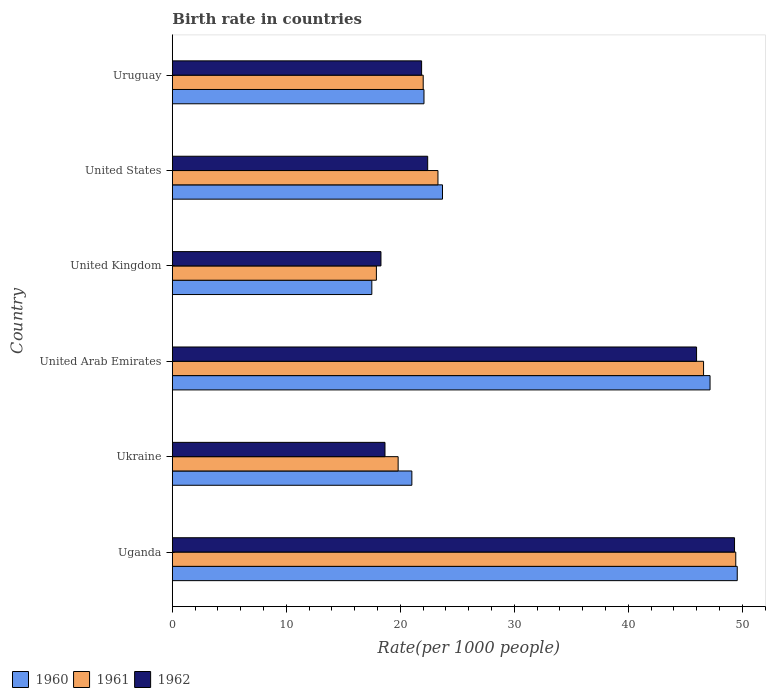What is the label of the 4th group of bars from the top?
Keep it short and to the point. United Arab Emirates. What is the birth rate in 1961 in Uruguay?
Offer a terse response. 22.01. Across all countries, what is the maximum birth rate in 1962?
Your answer should be compact. 49.32. In which country was the birth rate in 1960 maximum?
Give a very brief answer. Uganda. In which country was the birth rate in 1961 minimum?
Offer a very short reply. United Kingdom. What is the total birth rate in 1961 in the graph?
Your response must be concise. 179.04. What is the difference between the birth rate in 1961 in United Kingdom and that in Uruguay?
Make the answer very short. -4.11. What is the difference between the birth rate in 1961 in Uganda and the birth rate in 1962 in Ukraine?
Keep it short and to the point. 30.77. What is the average birth rate in 1962 per country?
Provide a short and direct response. 29.42. What is the difference between the birth rate in 1962 and birth rate in 1960 in United States?
Provide a short and direct response. -1.3. In how many countries, is the birth rate in 1960 greater than 40 ?
Provide a short and direct response. 2. What is the ratio of the birth rate in 1960 in Ukraine to that in United Arab Emirates?
Your response must be concise. 0.45. Is the birth rate in 1960 in Uganda less than that in United States?
Provide a succinct answer. No. What is the difference between the highest and the second highest birth rate in 1960?
Give a very brief answer. 2.39. What is the difference between the highest and the lowest birth rate in 1962?
Keep it short and to the point. 31.02. Is the sum of the birth rate in 1960 in Uganda and United Kingdom greater than the maximum birth rate in 1962 across all countries?
Ensure brevity in your answer.  Yes. What does the 1st bar from the top in United Arab Emirates represents?
Make the answer very short. 1962. Are all the bars in the graph horizontal?
Your answer should be compact. Yes. What is the difference between two consecutive major ticks on the X-axis?
Keep it short and to the point. 10. Does the graph contain any zero values?
Provide a succinct answer. No. Where does the legend appear in the graph?
Offer a very short reply. Bottom left. How are the legend labels stacked?
Provide a short and direct response. Horizontal. What is the title of the graph?
Offer a terse response. Birth rate in countries. What is the label or title of the X-axis?
Ensure brevity in your answer.  Rate(per 1000 people). What is the label or title of the Y-axis?
Make the answer very short. Country. What is the Rate(per 1000 people) in 1960 in Uganda?
Give a very brief answer. 49.56. What is the Rate(per 1000 people) of 1961 in Uganda?
Make the answer very short. 49.43. What is the Rate(per 1000 people) of 1962 in Uganda?
Give a very brief answer. 49.32. What is the Rate(per 1000 people) in 1960 in Ukraine?
Provide a succinct answer. 21.01. What is the Rate(per 1000 people) in 1961 in Ukraine?
Your answer should be compact. 19.81. What is the Rate(per 1000 people) of 1962 in Ukraine?
Give a very brief answer. 18.65. What is the Rate(per 1000 people) of 1960 in United Arab Emirates?
Your answer should be compact. 47.17. What is the Rate(per 1000 people) of 1961 in United Arab Emirates?
Offer a very short reply. 46.6. What is the Rate(per 1000 people) in 1962 in United Arab Emirates?
Keep it short and to the point. 45.99. What is the Rate(per 1000 people) of 1960 in United Kingdom?
Give a very brief answer. 17.5. What is the Rate(per 1000 people) of 1960 in United States?
Ensure brevity in your answer.  23.7. What is the Rate(per 1000 people) in 1961 in United States?
Provide a short and direct response. 23.3. What is the Rate(per 1000 people) of 1962 in United States?
Offer a terse response. 22.4. What is the Rate(per 1000 people) of 1960 in Uruguay?
Your answer should be very brief. 22.07. What is the Rate(per 1000 people) of 1961 in Uruguay?
Give a very brief answer. 22.01. What is the Rate(per 1000 people) in 1962 in Uruguay?
Provide a short and direct response. 21.87. Across all countries, what is the maximum Rate(per 1000 people) of 1960?
Your response must be concise. 49.56. Across all countries, what is the maximum Rate(per 1000 people) in 1961?
Your answer should be very brief. 49.43. Across all countries, what is the maximum Rate(per 1000 people) in 1962?
Provide a short and direct response. 49.32. Across all countries, what is the minimum Rate(per 1000 people) of 1960?
Your answer should be compact. 17.5. Across all countries, what is the minimum Rate(per 1000 people) in 1961?
Your answer should be very brief. 17.9. Across all countries, what is the minimum Rate(per 1000 people) in 1962?
Make the answer very short. 18.3. What is the total Rate(per 1000 people) of 1960 in the graph?
Offer a terse response. 181.01. What is the total Rate(per 1000 people) in 1961 in the graph?
Ensure brevity in your answer.  179.04. What is the total Rate(per 1000 people) in 1962 in the graph?
Your answer should be compact. 176.53. What is the difference between the Rate(per 1000 people) of 1960 in Uganda and that in Ukraine?
Give a very brief answer. 28.55. What is the difference between the Rate(per 1000 people) of 1961 in Uganda and that in Ukraine?
Ensure brevity in your answer.  29.62. What is the difference between the Rate(per 1000 people) of 1962 in Uganda and that in Ukraine?
Offer a terse response. 30.66. What is the difference between the Rate(per 1000 people) of 1960 in Uganda and that in United Arab Emirates?
Your answer should be very brief. 2.39. What is the difference between the Rate(per 1000 people) in 1961 in Uganda and that in United Arab Emirates?
Offer a very short reply. 2.83. What is the difference between the Rate(per 1000 people) in 1962 in Uganda and that in United Arab Emirates?
Keep it short and to the point. 3.33. What is the difference between the Rate(per 1000 people) in 1960 in Uganda and that in United Kingdom?
Your answer should be very brief. 32.06. What is the difference between the Rate(per 1000 people) in 1961 in Uganda and that in United Kingdom?
Provide a short and direct response. 31.53. What is the difference between the Rate(per 1000 people) of 1962 in Uganda and that in United Kingdom?
Your answer should be compact. 31.02. What is the difference between the Rate(per 1000 people) in 1960 in Uganda and that in United States?
Provide a short and direct response. 25.86. What is the difference between the Rate(per 1000 people) of 1961 in Uganda and that in United States?
Offer a terse response. 26.13. What is the difference between the Rate(per 1000 people) in 1962 in Uganda and that in United States?
Offer a terse response. 26.92. What is the difference between the Rate(per 1000 people) in 1960 in Uganda and that in Uruguay?
Provide a succinct answer. 27.48. What is the difference between the Rate(per 1000 people) in 1961 in Uganda and that in Uruguay?
Your answer should be compact. 27.42. What is the difference between the Rate(per 1000 people) in 1962 in Uganda and that in Uruguay?
Make the answer very short. 27.45. What is the difference between the Rate(per 1000 people) of 1960 in Ukraine and that in United Arab Emirates?
Offer a very short reply. -26.16. What is the difference between the Rate(per 1000 people) of 1961 in Ukraine and that in United Arab Emirates?
Give a very brief answer. -26.79. What is the difference between the Rate(per 1000 people) of 1962 in Ukraine and that in United Arab Emirates?
Offer a terse response. -27.33. What is the difference between the Rate(per 1000 people) of 1960 in Ukraine and that in United Kingdom?
Give a very brief answer. 3.51. What is the difference between the Rate(per 1000 people) in 1961 in Ukraine and that in United Kingdom?
Give a very brief answer. 1.91. What is the difference between the Rate(per 1000 people) in 1962 in Ukraine and that in United Kingdom?
Ensure brevity in your answer.  0.35. What is the difference between the Rate(per 1000 people) of 1960 in Ukraine and that in United States?
Ensure brevity in your answer.  -2.69. What is the difference between the Rate(per 1000 people) of 1961 in Ukraine and that in United States?
Ensure brevity in your answer.  -3.49. What is the difference between the Rate(per 1000 people) of 1962 in Ukraine and that in United States?
Make the answer very short. -3.75. What is the difference between the Rate(per 1000 people) of 1960 in Ukraine and that in Uruguay?
Provide a succinct answer. -1.06. What is the difference between the Rate(per 1000 people) in 1961 in Ukraine and that in Uruguay?
Keep it short and to the point. -2.2. What is the difference between the Rate(per 1000 people) of 1962 in Ukraine and that in Uruguay?
Offer a very short reply. -3.21. What is the difference between the Rate(per 1000 people) in 1960 in United Arab Emirates and that in United Kingdom?
Offer a terse response. 29.67. What is the difference between the Rate(per 1000 people) of 1961 in United Arab Emirates and that in United Kingdom?
Your answer should be very brief. 28.7. What is the difference between the Rate(per 1000 people) in 1962 in United Arab Emirates and that in United Kingdom?
Provide a short and direct response. 27.69. What is the difference between the Rate(per 1000 people) in 1960 in United Arab Emirates and that in United States?
Provide a short and direct response. 23.47. What is the difference between the Rate(per 1000 people) of 1961 in United Arab Emirates and that in United States?
Offer a terse response. 23.3. What is the difference between the Rate(per 1000 people) of 1962 in United Arab Emirates and that in United States?
Your answer should be compact. 23.59. What is the difference between the Rate(per 1000 people) in 1960 in United Arab Emirates and that in Uruguay?
Provide a short and direct response. 25.1. What is the difference between the Rate(per 1000 people) in 1961 in United Arab Emirates and that in Uruguay?
Keep it short and to the point. 24.59. What is the difference between the Rate(per 1000 people) of 1962 in United Arab Emirates and that in Uruguay?
Give a very brief answer. 24.12. What is the difference between the Rate(per 1000 people) in 1960 in United Kingdom and that in United States?
Your answer should be very brief. -6.2. What is the difference between the Rate(per 1000 people) in 1961 in United Kingdom and that in United States?
Provide a succinct answer. -5.4. What is the difference between the Rate(per 1000 people) of 1960 in United Kingdom and that in Uruguay?
Give a very brief answer. -4.58. What is the difference between the Rate(per 1000 people) of 1961 in United Kingdom and that in Uruguay?
Ensure brevity in your answer.  -4.11. What is the difference between the Rate(per 1000 people) of 1962 in United Kingdom and that in Uruguay?
Ensure brevity in your answer.  -3.57. What is the difference between the Rate(per 1000 people) in 1960 in United States and that in Uruguay?
Offer a very short reply. 1.62. What is the difference between the Rate(per 1000 people) of 1961 in United States and that in Uruguay?
Keep it short and to the point. 1.29. What is the difference between the Rate(per 1000 people) in 1962 in United States and that in Uruguay?
Provide a short and direct response. 0.53. What is the difference between the Rate(per 1000 people) in 1960 in Uganda and the Rate(per 1000 people) in 1961 in Ukraine?
Your answer should be very brief. 29.75. What is the difference between the Rate(per 1000 people) in 1960 in Uganda and the Rate(per 1000 people) in 1962 in Ukraine?
Your answer should be compact. 30.9. What is the difference between the Rate(per 1000 people) in 1961 in Uganda and the Rate(per 1000 people) in 1962 in Ukraine?
Your answer should be compact. 30.77. What is the difference between the Rate(per 1000 people) in 1960 in Uganda and the Rate(per 1000 people) in 1961 in United Arab Emirates?
Provide a succinct answer. 2.96. What is the difference between the Rate(per 1000 people) of 1960 in Uganda and the Rate(per 1000 people) of 1962 in United Arab Emirates?
Give a very brief answer. 3.57. What is the difference between the Rate(per 1000 people) in 1961 in Uganda and the Rate(per 1000 people) in 1962 in United Arab Emirates?
Provide a short and direct response. 3.44. What is the difference between the Rate(per 1000 people) in 1960 in Uganda and the Rate(per 1000 people) in 1961 in United Kingdom?
Your answer should be very brief. 31.66. What is the difference between the Rate(per 1000 people) of 1960 in Uganda and the Rate(per 1000 people) of 1962 in United Kingdom?
Ensure brevity in your answer.  31.26. What is the difference between the Rate(per 1000 people) in 1961 in Uganda and the Rate(per 1000 people) in 1962 in United Kingdom?
Offer a terse response. 31.13. What is the difference between the Rate(per 1000 people) in 1960 in Uganda and the Rate(per 1000 people) in 1961 in United States?
Offer a terse response. 26.26. What is the difference between the Rate(per 1000 people) in 1960 in Uganda and the Rate(per 1000 people) in 1962 in United States?
Your response must be concise. 27.16. What is the difference between the Rate(per 1000 people) in 1961 in Uganda and the Rate(per 1000 people) in 1962 in United States?
Provide a succinct answer. 27.03. What is the difference between the Rate(per 1000 people) in 1960 in Uganda and the Rate(per 1000 people) in 1961 in Uruguay?
Your answer should be compact. 27.55. What is the difference between the Rate(per 1000 people) in 1960 in Uganda and the Rate(per 1000 people) in 1962 in Uruguay?
Provide a short and direct response. 27.69. What is the difference between the Rate(per 1000 people) in 1961 in Uganda and the Rate(per 1000 people) in 1962 in Uruguay?
Your response must be concise. 27.56. What is the difference between the Rate(per 1000 people) in 1960 in Ukraine and the Rate(per 1000 people) in 1961 in United Arab Emirates?
Offer a very short reply. -25.59. What is the difference between the Rate(per 1000 people) of 1960 in Ukraine and the Rate(per 1000 people) of 1962 in United Arab Emirates?
Offer a very short reply. -24.98. What is the difference between the Rate(per 1000 people) of 1961 in Ukraine and the Rate(per 1000 people) of 1962 in United Arab Emirates?
Your answer should be very brief. -26.18. What is the difference between the Rate(per 1000 people) in 1960 in Ukraine and the Rate(per 1000 people) in 1961 in United Kingdom?
Your answer should be compact. 3.11. What is the difference between the Rate(per 1000 people) of 1960 in Ukraine and the Rate(per 1000 people) of 1962 in United Kingdom?
Provide a short and direct response. 2.71. What is the difference between the Rate(per 1000 people) in 1961 in Ukraine and the Rate(per 1000 people) in 1962 in United Kingdom?
Your answer should be very brief. 1.51. What is the difference between the Rate(per 1000 people) in 1960 in Ukraine and the Rate(per 1000 people) in 1961 in United States?
Provide a succinct answer. -2.29. What is the difference between the Rate(per 1000 people) of 1960 in Ukraine and the Rate(per 1000 people) of 1962 in United States?
Keep it short and to the point. -1.39. What is the difference between the Rate(per 1000 people) of 1961 in Ukraine and the Rate(per 1000 people) of 1962 in United States?
Ensure brevity in your answer.  -2.59. What is the difference between the Rate(per 1000 people) in 1960 in Ukraine and the Rate(per 1000 people) in 1961 in Uruguay?
Provide a short and direct response. -1. What is the difference between the Rate(per 1000 people) of 1960 in Ukraine and the Rate(per 1000 people) of 1962 in Uruguay?
Offer a terse response. -0.86. What is the difference between the Rate(per 1000 people) in 1961 in Ukraine and the Rate(per 1000 people) in 1962 in Uruguay?
Provide a succinct answer. -2.06. What is the difference between the Rate(per 1000 people) in 1960 in United Arab Emirates and the Rate(per 1000 people) in 1961 in United Kingdom?
Provide a succinct answer. 29.27. What is the difference between the Rate(per 1000 people) in 1960 in United Arab Emirates and the Rate(per 1000 people) in 1962 in United Kingdom?
Make the answer very short. 28.87. What is the difference between the Rate(per 1000 people) in 1961 in United Arab Emirates and the Rate(per 1000 people) in 1962 in United Kingdom?
Your answer should be very brief. 28.3. What is the difference between the Rate(per 1000 people) in 1960 in United Arab Emirates and the Rate(per 1000 people) in 1961 in United States?
Your answer should be compact. 23.87. What is the difference between the Rate(per 1000 people) of 1960 in United Arab Emirates and the Rate(per 1000 people) of 1962 in United States?
Offer a very short reply. 24.77. What is the difference between the Rate(per 1000 people) of 1961 in United Arab Emirates and the Rate(per 1000 people) of 1962 in United States?
Provide a short and direct response. 24.2. What is the difference between the Rate(per 1000 people) in 1960 in United Arab Emirates and the Rate(per 1000 people) in 1961 in Uruguay?
Give a very brief answer. 25.16. What is the difference between the Rate(per 1000 people) of 1960 in United Arab Emirates and the Rate(per 1000 people) of 1962 in Uruguay?
Provide a succinct answer. 25.3. What is the difference between the Rate(per 1000 people) of 1961 in United Arab Emirates and the Rate(per 1000 people) of 1962 in Uruguay?
Your answer should be very brief. 24.73. What is the difference between the Rate(per 1000 people) of 1960 in United Kingdom and the Rate(per 1000 people) of 1962 in United States?
Your answer should be compact. -4.9. What is the difference between the Rate(per 1000 people) of 1961 in United Kingdom and the Rate(per 1000 people) of 1962 in United States?
Provide a short and direct response. -4.5. What is the difference between the Rate(per 1000 people) in 1960 in United Kingdom and the Rate(per 1000 people) in 1961 in Uruguay?
Keep it short and to the point. -4.51. What is the difference between the Rate(per 1000 people) in 1960 in United Kingdom and the Rate(per 1000 people) in 1962 in Uruguay?
Keep it short and to the point. -4.37. What is the difference between the Rate(per 1000 people) of 1961 in United Kingdom and the Rate(per 1000 people) of 1962 in Uruguay?
Offer a very short reply. -3.97. What is the difference between the Rate(per 1000 people) of 1960 in United States and the Rate(per 1000 people) of 1961 in Uruguay?
Provide a short and direct response. 1.69. What is the difference between the Rate(per 1000 people) of 1960 in United States and the Rate(per 1000 people) of 1962 in Uruguay?
Ensure brevity in your answer.  1.83. What is the difference between the Rate(per 1000 people) in 1961 in United States and the Rate(per 1000 people) in 1962 in Uruguay?
Ensure brevity in your answer.  1.43. What is the average Rate(per 1000 people) of 1960 per country?
Provide a succinct answer. 30.17. What is the average Rate(per 1000 people) of 1961 per country?
Your response must be concise. 29.84. What is the average Rate(per 1000 people) in 1962 per country?
Your answer should be compact. 29.42. What is the difference between the Rate(per 1000 people) in 1960 and Rate(per 1000 people) in 1961 in Uganda?
Provide a short and direct response. 0.13. What is the difference between the Rate(per 1000 people) in 1960 and Rate(per 1000 people) in 1962 in Uganda?
Give a very brief answer. 0.24. What is the difference between the Rate(per 1000 people) of 1961 and Rate(per 1000 people) of 1962 in Uganda?
Give a very brief answer. 0.11. What is the difference between the Rate(per 1000 people) of 1960 and Rate(per 1000 people) of 1961 in Ukraine?
Offer a very short reply. 1.2. What is the difference between the Rate(per 1000 people) of 1960 and Rate(per 1000 people) of 1962 in Ukraine?
Give a very brief answer. 2.36. What is the difference between the Rate(per 1000 people) of 1961 and Rate(per 1000 people) of 1962 in Ukraine?
Provide a succinct answer. 1.15. What is the difference between the Rate(per 1000 people) of 1960 and Rate(per 1000 people) of 1961 in United Arab Emirates?
Your response must be concise. 0.57. What is the difference between the Rate(per 1000 people) of 1960 and Rate(per 1000 people) of 1962 in United Arab Emirates?
Your response must be concise. 1.18. What is the difference between the Rate(per 1000 people) of 1961 and Rate(per 1000 people) of 1962 in United Arab Emirates?
Provide a short and direct response. 0.61. What is the difference between the Rate(per 1000 people) of 1961 and Rate(per 1000 people) of 1962 in United Kingdom?
Offer a very short reply. -0.4. What is the difference between the Rate(per 1000 people) of 1960 and Rate(per 1000 people) of 1961 in United States?
Ensure brevity in your answer.  0.4. What is the difference between the Rate(per 1000 people) of 1961 and Rate(per 1000 people) of 1962 in United States?
Ensure brevity in your answer.  0.9. What is the difference between the Rate(per 1000 people) in 1960 and Rate(per 1000 people) in 1961 in Uruguay?
Provide a succinct answer. 0.07. What is the difference between the Rate(per 1000 people) in 1960 and Rate(per 1000 people) in 1962 in Uruguay?
Offer a terse response. 0.21. What is the difference between the Rate(per 1000 people) of 1961 and Rate(per 1000 people) of 1962 in Uruguay?
Provide a short and direct response. 0.14. What is the ratio of the Rate(per 1000 people) in 1960 in Uganda to that in Ukraine?
Your answer should be compact. 2.36. What is the ratio of the Rate(per 1000 people) in 1961 in Uganda to that in Ukraine?
Provide a succinct answer. 2.5. What is the ratio of the Rate(per 1000 people) in 1962 in Uganda to that in Ukraine?
Give a very brief answer. 2.64. What is the ratio of the Rate(per 1000 people) in 1960 in Uganda to that in United Arab Emirates?
Your response must be concise. 1.05. What is the ratio of the Rate(per 1000 people) of 1961 in Uganda to that in United Arab Emirates?
Ensure brevity in your answer.  1.06. What is the ratio of the Rate(per 1000 people) in 1962 in Uganda to that in United Arab Emirates?
Give a very brief answer. 1.07. What is the ratio of the Rate(per 1000 people) in 1960 in Uganda to that in United Kingdom?
Your response must be concise. 2.83. What is the ratio of the Rate(per 1000 people) in 1961 in Uganda to that in United Kingdom?
Give a very brief answer. 2.76. What is the ratio of the Rate(per 1000 people) of 1962 in Uganda to that in United Kingdom?
Your answer should be very brief. 2.69. What is the ratio of the Rate(per 1000 people) of 1960 in Uganda to that in United States?
Give a very brief answer. 2.09. What is the ratio of the Rate(per 1000 people) of 1961 in Uganda to that in United States?
Your answer should be compact. 2.12. What is the ratio of the Rate(per 1000 people) in 1962 in Uganda to that in United States?
Offer a terse response. 2.2. What is the ratio of the Rate(per 1000 people) in 1960 in Uganda to that in Uruguay?
Provide a succinct answer. 2.24. What is the ratio of the Rate(per 1000 people) of 1961 in Uganda to that in Uruguay?
Offer a terse response. 2.25. What is the ratio of the Rate(per 1000 people) of 1962 in Uganda to that in Uruguay?
Provide a succinct answer. 2.26. What is the ratio of the Rate(per 1000 people) of 1960 in Ukraine to that in United Arab Emirates?
Keep it short and to the point. 0.45. What is the ratio of the Rate(per 1000 people) in 1961 in Ukraine to that in United Arab Emirates?
Your response must be concise. 0.42. What is the ratio of the Rate(per 1000 people) in 1962 in Ukraine to that in United Arab Emirates?
Provide a succinct answer. 0.41. What is the ratio of the Rate(per 1000 people) in 1960 in Ukraine to that in United Kingdom?
Provide a short and direct response. 1.2. What is the ratio of the Rate(per 1000 people) of 1961 in Ukraine to that in United Kingdom?
Offer a terse response. 1.11. What is the ratio of the Rate(per 1000 people) in 1962 in Ukraine to that in United Kingdom?
Provide a succinct answer. 1.02. What is the ratio of the Rate(per 1000 people) in 1960 in Ukraine to that in United States?
Your answer should be compact. 0.89. What is the ratio of the Rate(per 1000 people) in 1961 in Ukraine to that in United States?
Give a very brief answer. 0.85. What is the ratio of the Rate(per 1000 people) of 1962 in Ukraine to that in United States?
Your response must be concise. 0.83. What is the ratio of the Rate(per 1000 people) in 1960 in Ukraine to that in Uruguay?
Your answer should be compact. 0.95. What is the ratio of the Rate(per 1000 people) in 1961 in Ukraine to that in Uruguay?
Provide a succinct answer. 0.9. What is the ratio of the Rate(per 1000 people) in 1962 in Ukraine to that in Uruguay?
Provide a succinct answer. 0.85. What is the ratio of the Rate(per 1000 people) in 1960 in United Arab Emirates to that in United Kingdom?
Make the answer very short. 2.7. What is the ratio of the Rate(per 1000 people) in 1961 in United Arab Emirates to that in United Kingdom?
Offer a very short reply. 2.6. What is the ratio of the Rate(per 1000 people) of 1962 in United Arab Emirates to that in United Kingdom?
Offer a terse response. 2.51. What is the ratio of the Rate(per 1000 people) in 1960 in United Arab Emirates to that in United States?
Make the answer very short. 1.99. What is the ratio of the Rate(per 1000 people) of 1961 in United Arab Emirates to that in United States?
Keep it short and to the point. 2. What is the ratio of the Rate(per 1000 people) of 1962 in United Arab Emirates to that in United States?
Give a very brief answer. 2.05. What is the ratio of the Rate(per 1000 people) in 1960 in United Arab Emirates to that in Uruguay?
Offer a terse response. 2.14. What is the ratio of the Rate(per 1000 people) in 1961 in United Arab Emirates to that in Uruguay?
Provide a short and direct response. 2.12. What is the ratio of the Rate(per 1000 people) in 1962 in United Arab Emirates to that in Uruguay?
Offer a terse response. 2.1. What is the ratio of the Rate(per 1000 people) in 1960 in United Kingdom to that in United States?
Give a very brief answer. 0.74. What is the ratio of the Rate(per 1000 people) of 1961 in United Kingdom to that in United States?
Your answer should be very brief. 0.77. What is the ratio of the Rate(per 1000 people) in 1962 in United Kingdom to that in United States?
Your response must be concise. 0.82. What is the ratio of the Rate(per 1000 people) of 1960 in United Kingdom to that in Uruguay?
Make the answer very short. 0.79. What is the ratio of the Rate(per 1000 people) of 1961 in United Kingdom to that in Uruguay?
Give a very brief answer. 0.81. What is the ratio of the Rate(per 1000 people) in 1962 in United Kingdom to that in Uruguay?
Give a very brief answer. 0.84. What is the ratio of the Rate(per 1000 people) in 1960 in United States to that in Uruguay?
Ensure brevity in your answer.  1.07. What is the ratio of the Rate(per 1000 people) of 1961 in United States to that in Uruguay?
Provide a short and direct response. 1.06. What is the ratio of the Rate(per 1000 people) of 1962 in United States to that in Uruguay?
Your answer should be compact. 1.02. What is the difference between the highest and the second highest Rate(per 1000 people) of 1960?
Your answer should be compact. 2.39. What is the difference between the highest and the second highest Rate(per 1000 people) in 1961?
Offer a very short reply. 2.83. What is the difference between the highest and the second highest Rate(per 1000 people) in 1962?
Offer a very short reply. 3.33. What is the difference between the highest and the lowest Rate(per 1000 people) in 1960?
Your response must be concise. 32.06. What is the difference between the highest and the lowest Rate(per 1000 people) of 1961?
Your answer should be compact. 31.53. What is the difference between the highest and the lowest Rate(per 1000 people) in 1962?
Keep it short and to the point. 31.02. 